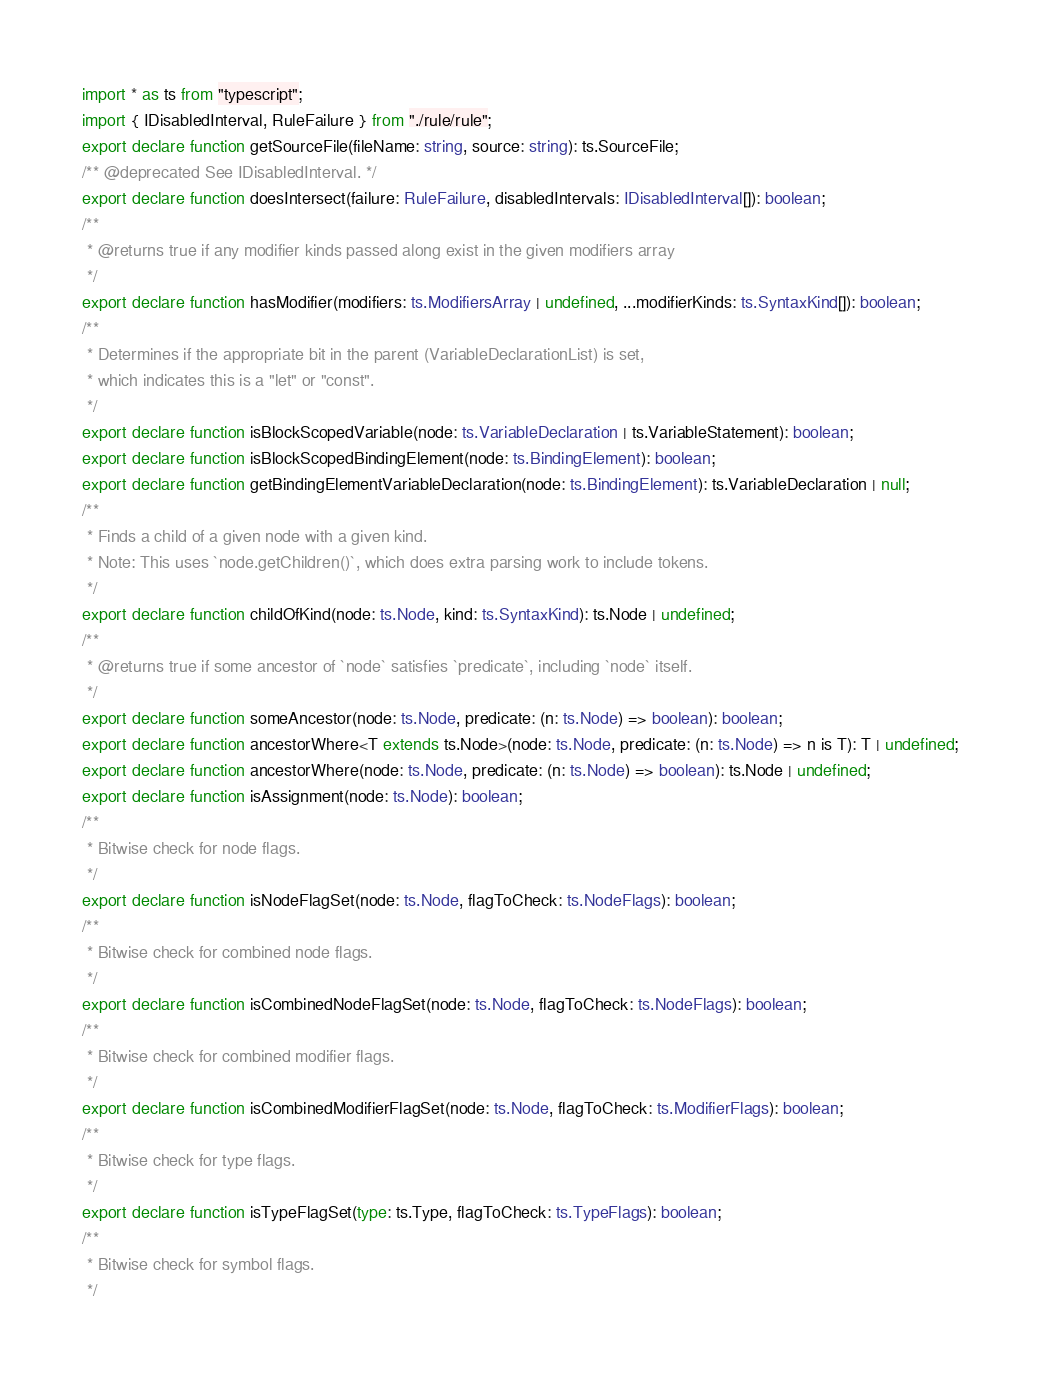Convert code to text. <code><loc_0><loc_0><loc_500><loc_500><_TypeScript_>import * as ts from "typescript";
import { IDisabledInterval, RuleFailure } from "./rule/rule";
export declare function getSourceFile(fileName: string, source: string): ts.SourceFile;
/** @deprecated See IDisabledInterval. */
export declare function doesIntersect(failure: RuleFailure, disabledIntervals: IDisabledInterval[]): boolean;
/**
 * @returns true if any modifier kinds passed along exist in the given modifiers array
 */
export declare function hasModifier(modifiers: ts.ModifiersArray | undefined, ...modifierKinds: ts.SyntaxKind[]): boolean;
/**
 * Determines if the appropriate bit in the parent (VariableDeclarationList) is set,
 * which indicates this is a "let" or "const".
 */
export declare function isBlockScopedVariable(node: ts.VariableDeclaration | ts.VariableStatement): boolean;
export declare function isBlockScopedBindingElement(node: ts.BindingElement): boolean;
export declare function getBindingElementVariableDeclaration(node: ts.BindingElement): ts.VariableDeclaration | null;
/**
 * Finds a child of a given node with a given kind.
 * Note: This uses `node.getChildren()`, which does extra parsing work to include tokens.
 */
export declare function childOfKind(node: ts.Node, kind: ts.SyntaxKind): ts.Node | undefined;
/**
 * @returns true if some ancestor of `node` satisfies `predicate`, including `node` itself.
 */
export declare function someAncestor(node: ts.Node, predicate: (n: ts.Node) => boolean): boolean;
export declare function ancestorWhere<T extends ts.Node>(node: ts.Node, predicate: (n: ts.Node) => n is T): T | undefined;
export declare function ancestorWhere(node: ts.Node, predicate: (n: ts.Node) => boolean): ts.Node | undefined;
export declare function isAssignment(node: ts.Node): boolean;
/**
 * Bitwise check for node flags.
 */
export declare function isNodeFlagSet(node: ts.Node, flagToCheck: ts.NodeFlags): boolean;
/**
 * Bitwise check for combined node flags.
 */
export declare function isCombinedNodeFlagSet(node: ts.Node, flagToCheck: ts.NodeFlags): boolean;
/**
 * Bitwise check for combined modifier flags.
 */
export declare function isCombinedModifierFlagSet(node: ts.Node, flagToCheck: ts.ModifierFlags): boolean;
/**
 * Bitwise check for type flags.
 */
export declare function isTypeFlagSet(type: ts.Type, flagToCheck: ts.TypeFlags): boolean;
/**
 * Bitwise check for symbol flags.
 */</code> 